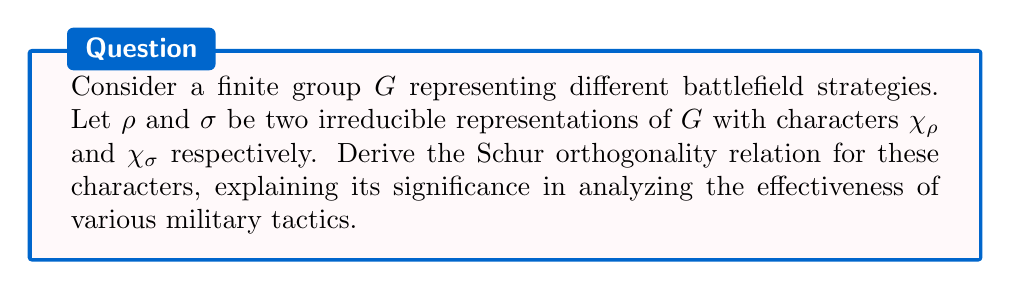Could you help me with this problem? 1) First, recall that for a finite group $G$, the Schur orthogonality relation for characters is given by:

   $$\frac{1}{|G|} \sum_{g \in G} \chi_\rho(g) \overline{\chi_\sigma(g)} = \delta_{\rho\sigma}$$

   where $\delta_{\rho\sigma}$ is the Kronecker delta.

2) To derive this, we start with the orthogonality of matrix elements:

   $$\sum_{g \in G} \rho_{ij}(g) \overline{\sigma_{kl}(g)} = \frac{|G|}{d_\rho} \delta_{\rho\sigma} \delta_{ik} \delta_{jl}$$

   where $d_\rho$ is the dimension of the representation $\rho$.

3) Now, we sum over $i=j$ and $k=l$ to get the character relation:

   $$\sum_{i,k} \sum_{g \in G} \rho_{ii}(g) \overline{\sigma_{kk}(g)} = \frac{|G|}{d_\rho} \delta_{\rho\sigma} \sum_{i,k} \delta_{ik} = |G| \delta_{\rho\sigma}$$

4) The left-hand side becomes:

   $$\sum_{g \in G} \left(\sum_i \rho_{ii}(g)\right) \left(\sum_k \overline{\sigma_{kk}(g)}\right) = \sum_{g \in G} \chi_\rho(g) \overline{\chi_\sigma(g)}$$

5) Equating these and dividing by $|G|$ gives us the Schur orthogonality relation:

   $$\frac{1}{|G|} \sum_{g \in G} \chi_\rho(g) \overline{\chi_\sigma(g)} = \delta_{\rho\sigma}$$

6) In the context of battlefield strategies, this relation implies that different irreducible representations (corresponding to distinct tactical approaches) are orthogonal. This means that fundamentally different strategies cannot be mixed or confused, ensuring clarity in tactical planning.

7) The relation also allows us to decompose complex battle plans into simpler, irreducible components, facilitating analysis of their effectiveness and potential outcomes.
Answer: $$\frac{1}{|G|} \sum_{g \in G} \chi_\rho(g) \overline{\chi_\sigma(g)} = \delta_{\rho\sigma}$$ 